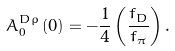Convert formula to latex. <formula><loc_0><loc_0><loc_500><loc_500>A _ { 0 } ^ { D \rho } \left ( 0 \right ) = - \frac { 1 } { 4 } \left ( \frac { f _ { D } } { f _ { \pi } } \right ) .</formula> 